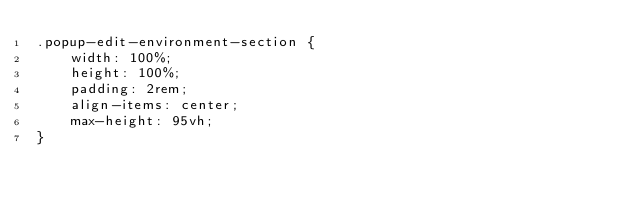Convert code to text. <code><loc_0><loc_0><loc_500><loc_500><_CSS_>.popup-edit-environment-section {
    width: 100%;
    height: 100%;
    padding: 2rem;
    align-items: center;
    max-height: 95vh;
}
</code> 